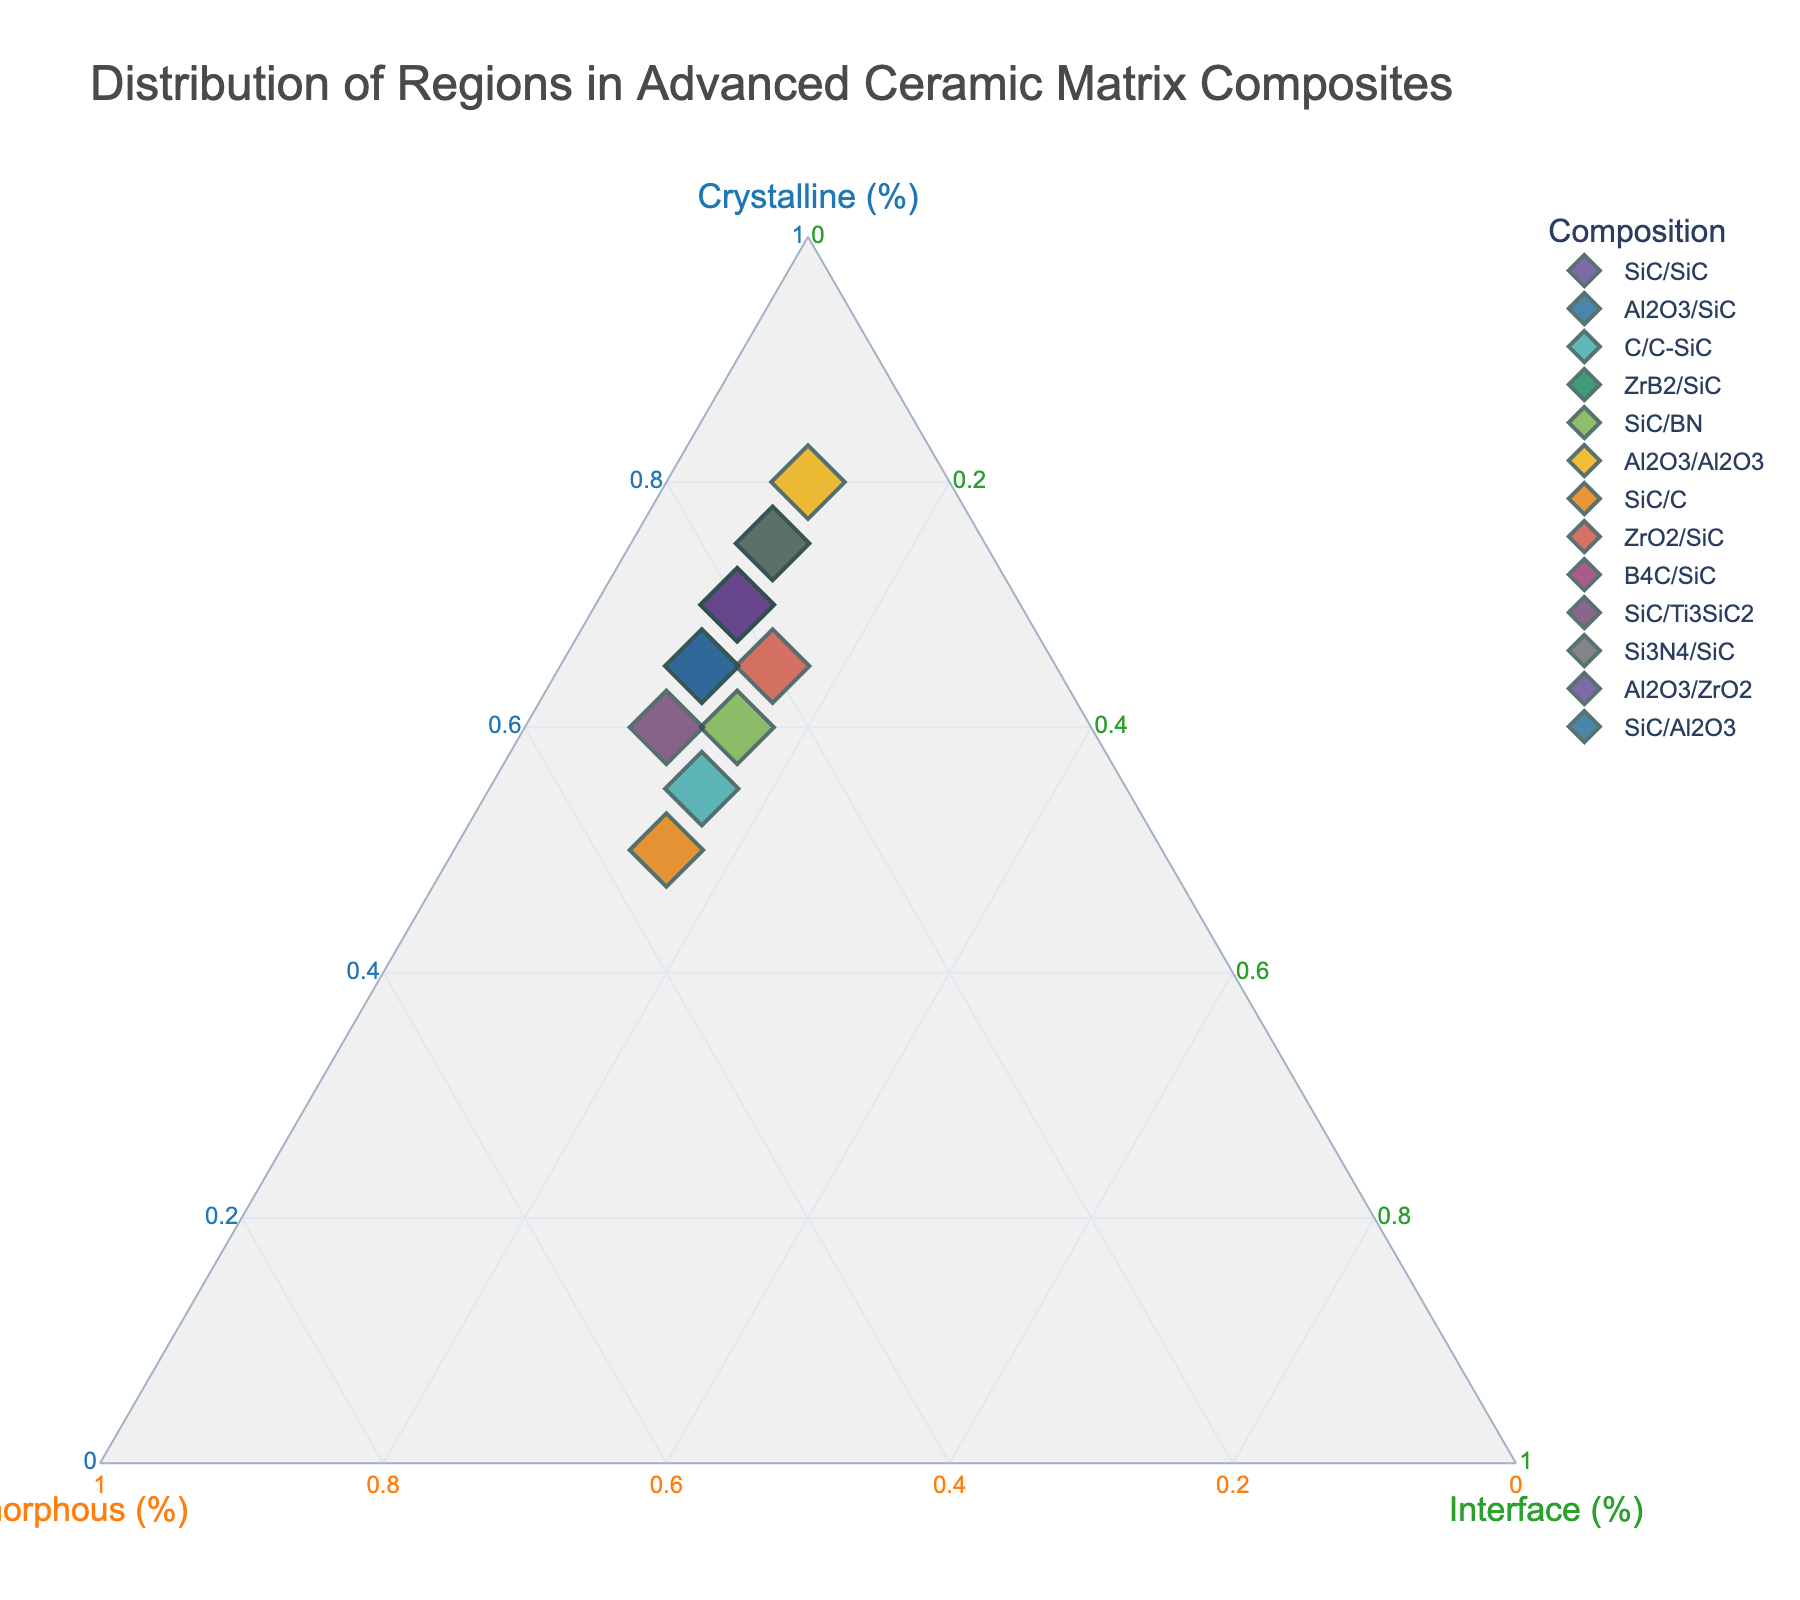How many compositions are represented in the ternary plot? To determine the number of compositions, count the distinct points (data entries) on the plot, each representing a different composition. Each has a unique label and color.
Answer: 13 Which composition has the highest percentage of crystalline region? Examine the plot and identify the point that is positioned closest to the apex representing the crystalline region. In this case, "Al2O3/Al2O3" is closest to the crystalline apex with 80%.
Answer: Al2O3/Al2O3 Which compositions have an equal percentage of the interface region? Identify the compositions with points on the same horizontal level in the triangular plot, specifically at the same percentage of the interface component. Compositions "SiC/SiC," "Al2O3/SiC," "ZrB2/SiC," "Al2O3/Al2O3," "B4C/SiC," "Si3N4/SiC," and "Al2O3/ZrO2" all have 10% in the interface region.
Answer: SiC/SiC, Al2O3/SiC, ZrB2/SiC, Al2O3/Al2O3, B4C/SiC, Si3N4/SiC, Al2O3/ZrO2 Which composition(s) is/are closest to having a balanced distribution of crystalline, amorphous, and interface regions? Look for compositions that lie near the centroid of the ternary plot, where all three regions (crystalline, amorphous, and interface) would be close to being equal. "SiC/C" with a relatively balanced distribution at 50%, 35%, and 15% appears to be the most balanced.
Answer: SiC/C Which compositions feature a greater percentage of amorphous region than crystalline region? Find compositions with points closer to the amorphous axis than the crystalline axis. "C/C-SiC" (55% Crystalline, 30% Amorphous, 15% Interface) and "SiC/C" (50% Crystalline, 35% Amorphous, 15% Interface) fit this criterion.
Answer: C/C-SiC, SiC/C What is the average percentage of the interface region across all compositions? Sum all the interface percentages and divide by the number of compositions. The percentages are: 10, 10, 15, 10, 15, 10, 15, 15, 10, 10, 10, 10, 10. Total = 145%. Average = 145% / 13 = 11.15%.
Answer: 11.15% Between "SiC/SiC" and "SiC/Ti3SiC2," which composition has a higher percentage of the amorphous region? Compare the positions of "SiC/SiC" (25% amorphous) and "SiC/Ti3SiC2" (30% amorphous). "SiC/Ti3SiC2" has a higher percentage of the amorphous region.
Answer: SiC/Ti3SiC2 What is the combined percentage of the crystalline and amorphous regions in "Al2O3/SiC"? Add the crystalline and amorphous percentages for "Al2O3/SiC" (70% crystalline + 20% amorphous = 90%).
Answer: 90% How does the crystalline region of "SiC/BN" compare to that of "ZrO2/SiC"? Compare the percentage of crystalline regions of "SiC/BN" (60%) and "ZrO2/SiC" (65%). "ZrO2/SiC" has a higher percentage of the crystalline region.
Answer: ZrO2/SiC Which composition has the lowest amorphous region percentage? Identify the point closest to the vertex opposite of the amorphous axis, indicating the least percentage of the amorphous region. "Al2O3/Al2O3" has only 10% in the amorphous region.
Answer: Al2O3/Al2O3 